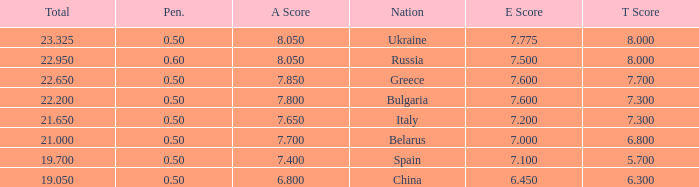What E score has the T score of 8 and a number smaller than 22.95? None. 